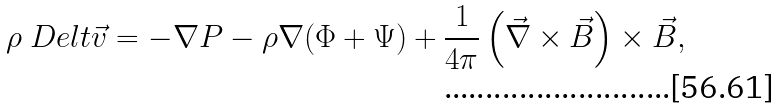Convert formula to latex. <formula><loc_0><loc_0><loc_500><loc_500>\rho \ D e l { t } { \vec { v } } = - \nabla P - \rho \nabla ( \Phi + \Psi ) + \frac { 1 } { 4 \pi } \left ( \vec { \nabla } \times \vec { B } \right ) \times \vec { B } ,</formula> 